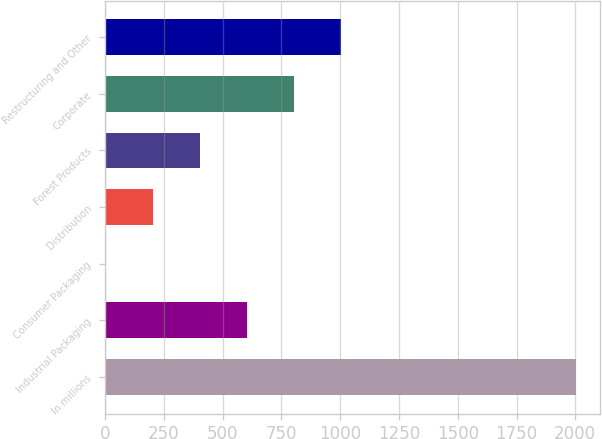Convert chart. <chart><loc_0><loc_0><loc_500><loc_500><bar_chart><fcel>In millions<fcel>Industrial Packaging<fcel>Consumer Packaging<fcel>Distribution<fcel>Forest Products<fcel>Corporate<fcel>Restructuring and Other<nl><fcel>2005<fcel>602.9<fcel>2<fcel>202.3<fcel>402.6<fcel>803.2<fcel>1003.5<nl></chart> 